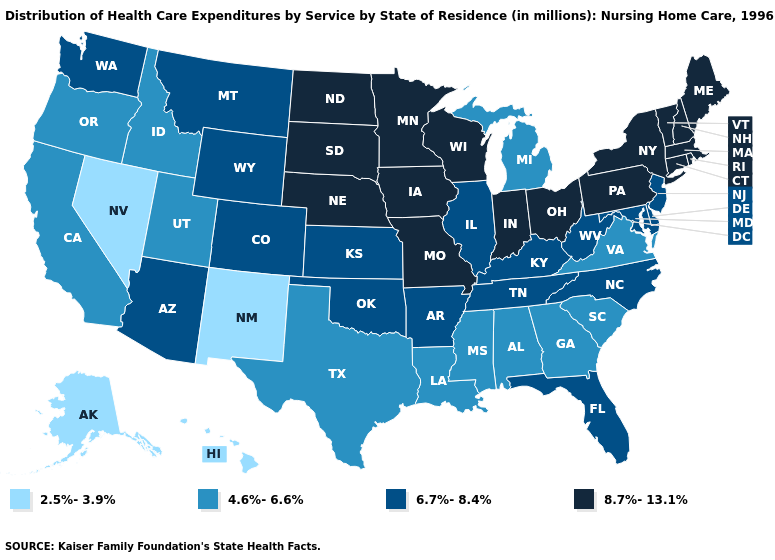What is the lowest value in states that border Nevada?
Quick response, please. 4.6%-6.6%. What is the value of Michigan?
Quick response, please. 4.6%-6.6%. What is the highest value in the South ?
Give a very brief answer. 6.7%-8.4%. Name the states that have a value in the range 8.7%-13.1%?
Short answer required. Connecticut, Indiana, Iowa, Maine, Massachusetts, Minnesota, Missouri, Nebraska, New Hampshire, New York, North Dakota, Ohio, Pennsylvania, Rhode Island, South Dakota, Vermont, Wisconsin. What is the value of Virginia?
Short answer required. 4.6%-6.6%. Which states have the lowest value in the USA?
Keep it brief. Alaska, Hawaii, Nevada, New Mexico. What is the lowest value in states that border Oklahoma?
Short answer required. 2.5%-3.9%. What is the lowest value in the South?
Concise answer only. 4.6%-6.6%. Does Nevada have the lowest value in the USA?
Be succinct. Yes. Does Louisiana have the highest value in the South?
Be succinct. No. What is the value of Wyoming?
Keep it brief. 6.7%-8.4%. Does the map have missing data?
Answer briefly. No. Name the states that have a value in the range 8.7%-13.1%?
Write a very short answer. Connecticut, Indiana, Iowa, Maine, Massachusetts, Minnesota, Missouri, Nebraska, New Hampshire, New York, North Dakota, Ohio, Pennsylvania, Rhode Island, South Dakota, Vermont, Wisconsin. Does New Jersey have the highest value in the Northeast?
Concise answer only. No. What is the value of Rhode Island?
Quick response, please. 8.7%-13.1%. 